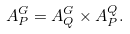<formula> <loc_0><loc_0><loc_500><loc_500>A _ { P } ^ { G } = A _ { Q } ^ { G } \times A _ { P } ^ { Q } .</formula> 